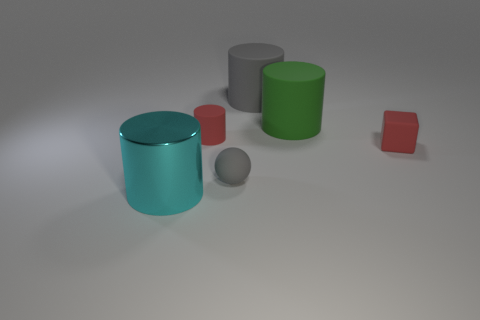Is there anything else that is made of the same material as the large cyan thing?
Keep it short and to the point. No. Is there a matte cylinder that has the same color as the matte ball?
Your answer should be very brief. Yes. There is a green thing that is the same shape as the large cyan metallic thing; what material is it?
Offer a very short reply. Rubber. There is a small thing behind the tiny rubber cube; is its shape the same as the tiny thing that is to the right of the large green thing?
Make the answer very short. No. Is the number of small matte things greater than the number of cylinders?
Give a very brief answer. No. The rubber block is what size?
Provide a succinct answer. Small. How many other things are the same color as the small matte cylinder?
Provide a short and direct response. 1. Are the tiny red object behind the small red matte cube and the red block made of the same material?
Your answer should be very brief. Yes. Is the number of tiny gray matte spheres that are in front of the cyan shiny thing less than the number of big rubber cylinders that are in front of the small ball?
Your answer should be very brief. No. What number of other things are there of the same material as the block
Offer a very short reply. 4. 